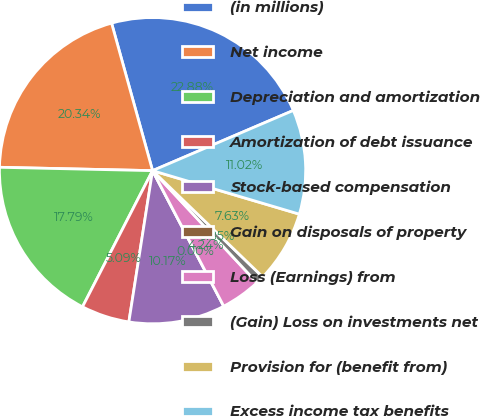<chart> <loc_0><loc_0><loc_500><loc_500><pie_chart><fcel>(in millions)<fcel>Net income<fcel>Depreciation and amortization<fcel>Amortization of debt issuance<fcel>Stock-based compensation<fcel>Gain on disposals of property<fcel>Loss (Earnings) from<fcel>(Gain) Loss on investments net<fcel>Provision for (benefit from)<fcel>Excess income tax benefits<nl><fcel>22.88%<fcel>20.34%<fcel>17.79%<fcel>5.09%<fcel>10.17%<fcel>0.0%<fcel>4.24%<fcel>0.85%<fcel>7.63%<fcel>11.02%<nl></chart> 